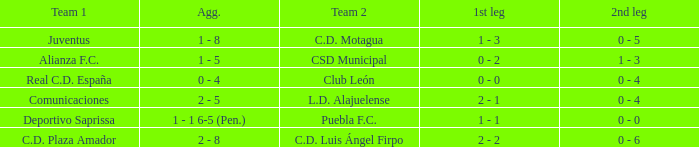What is the 1st leg where Team 1 is C.D. Plaza Amador? 2 - 2. 